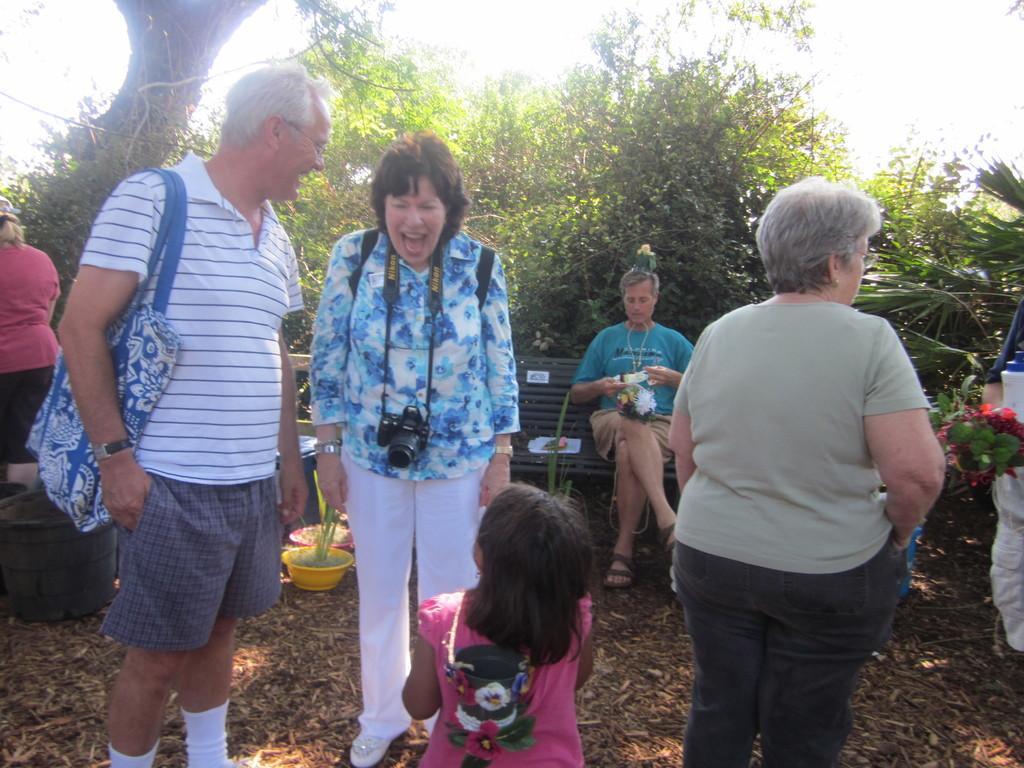Please provide a concise description of this image. In this image I can see people where one is sitting on a bench and rest all are standing. I can see few of them are carrying bags and here I can see a camera. I can also see number of trees and few plants in pots. 